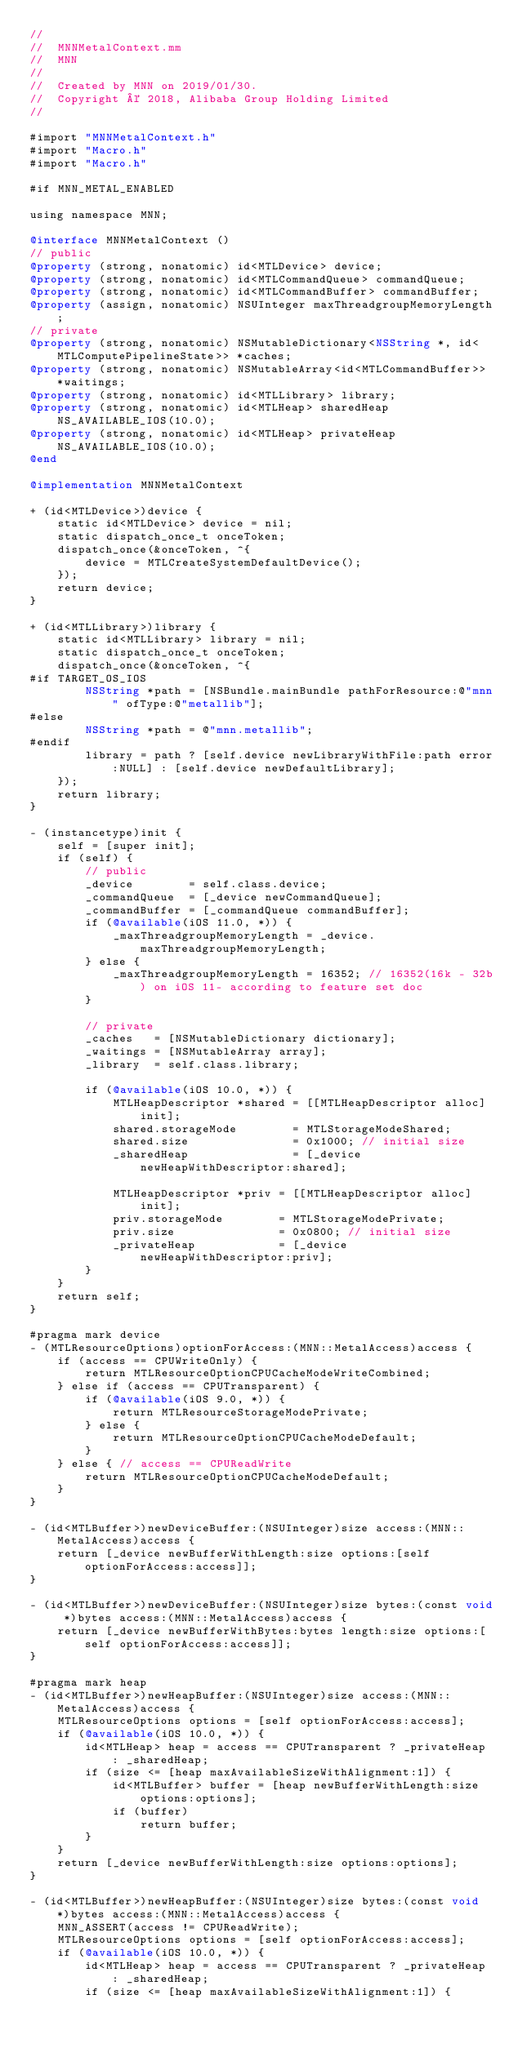<code> <loc_0><loc_0><loc_500><loc_500><_ObjectiveC_>//
//  MNNMetalContext.mm
//  MNN
//
//  Created by MNN on 2019/01/30.
//  Copyright © 2018, Alibaba Group Holding Limited
//

#import "MNNMetalContext.h"
#import "Macro.h"
#import "Macro.h"

#if MNN_METAL_ENABLED

using namespace MNN;

@interface MNNMetalContext ()
// public
@property (strong, nonatomic) id<MTLDevice> device;
@property (strong, nonatomic) id<MTLCommandQueue> commandQueue;
@property (strong, nonatomic) id<MTLCommandBuffer> commandBuffer;
@property (assign, nonatomic) NSUInteger maxThreadgroupMemoryLength;
// private
@property (strong, nonatomic) NSMutableDictionary<NSString *, id<MTLComputePipelineState>> *caches;
@property (strong, nonatomic) NSMutableArray<id<MTLCommandBuffer>> *waitings;
@property (strong, nonatomic) id<MTLLibrary> library;
@property (strong, nonatomic) id<MTLHeap> sharedHeap NS_AVAILABLE_IOS(10.0);
@property (strong, nonatomic) id<MTLHeap> privateHeap NS_AVAILABLE_IOS(10.0);
@end

@implementation MNNMetalContext

+ (id<MTLDevice>)device {
    static id<MTLDevice> device = nil;
    static dispatch_once_t onceToken;
    dispatch_once(&onceToken, ^{
        device = MTLCreateSystemDefaultDevice();
    });
    return device;
}

+ (id<MTLLibrary>)library {
    static id<MTLLibrary> library = nil;
    static dispatch_once_t onceToken;
    dispatch_once(&onceToken, ^{
#if TARGET_OS_IOS
        NSString *path = [NSBundle.mainBundle pathForResource:@"mnn" ofType:@"metallib"];
#else
        NSString *path = @"mnn.metallib";
#endif
        library = path ? [self.device newLibraryWithFile:path error:NULL] : [self.device newDefaultLibrary];
    });
    return library;
}

- (instancetype)init {
    self = [super init];
    if (self) {
        // public
        _device        = self.class.device;
        _commandQueue  = [_device newCommandQueue];
        _commandBuffer = [_commandQueue commandBuffer];
        if (@available(iOS 11.0, *)) {
            _maxThreadgroupMemoryLength = _device.maxThreadgroupMemoryLength;
        } else {
            _maxThreadgroupMemoryLength = 16352; // 16352(16k - 32b) on iOS 11- according to feature set doc
        }

        // private
        _caches   = [NSMutableDictionary dictionary];
        _waitings = [NSMutableArray array];
        _library  = self.class.library;

        if (@available(iOS 10.0, *)) {
            MTLHeapDescriptor *shared = [[MTLHeapDescriptor alloc] init];
            shared.storageMode        = MTLStorageModeShared;
            shared.size               = 0x1000; // initial size
            _sharedHeap               = [_device newHeapWithDescriptor:shared];

            MTLHeapDescriptor *priv = [[MTLHeapDescriptor alloc] init];
            priv.storageMode        = MTLStorageModePrivate;
            priv.size               = 0x0800; // initial size
            _privateHeap            = [_device newHeapWithDescriptor:priv];
        }
    }
    return self;
}

#pragma mark device
- (MTLResourceOptions)optionForAccess:(MNN::MetalAccess)access {
    if (access == CPUWriteOnly) {
        return MTLResourceOptionCPUCacheModeWriteCombined;
    } else if (access == CPUTransparent) {
        if (@available(iOS 9.0, *)) {
            return MTLResourceStorageModePrivate;
        } else {
            return MTLResourceOptionCPUCacheModeDefault;
        }
    } else { // access == CPUReadWrite
        return MTLResourceOptionCPUCacheModeDefault;
    }
}

- (id<MTLBuffer>)newDeviceBuffer:(NSUInteger)size access:(MNN::MetalAccess)access {
    return [_device newBufferWithLength:size options:[self optionForAccess:access]];
}

- (id<MTLBuffer>)newDeviceBuffer:(NSUInteger)size bytes:(const void *)bytes access:(MNN::MetalAccess)access {
    return [_device newBufferWithBytes:bytes length:size options:[self optionForAccess:access]];
}

#pragma mark heap
- (id<MTLBuffer>)newHeapBuffer:(NSUInteger)size access:(MNN::MetalAccess)access {
    MTLResourceOptions options = [self optionForAccess:access];
    if (@available(iOS 10.0, *)) {
        id<MTLHeap> heap = access == CPUTransparent ? _privateHeap : _sharedHeap;
        if (size <= [heap maxAvailableSizeWithAlignment:1]) {
            id<MTLBuffer> buffer = [heap newBufferWithLength:size options:options];
            if (buffer)
                return buffer;
        }
    }
    return [_device newBufferWithLength:size options:options];
}

- (id<MTLBuffer>)newHeapBuffer:(NSUInteger)size bytes:(const void *)bytes access:(MNN::MetalAccess)access {
    MNN_ASSERT(access != CPUReadWrite);
    MTLResourceOptions options = [self optionForAccess:access];
    if (@available(iOS 10.0, *)) {
        id<MTLHeap> heap = access == CPUTransparent ? _privateHeap : _sharedHeap;
        if (size <= [heap maxAvailableSizeWithAlignment:1]) {</code> 